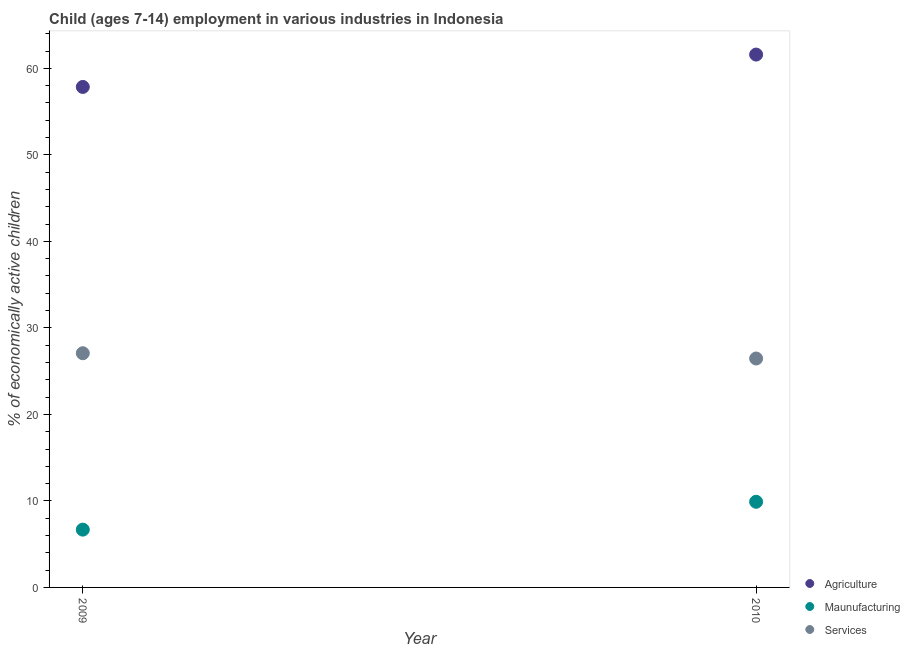How many different coloured dotlines are there?
Give a very brief answer. 3. What is the percentage of economically active children in manufacturing in 2009?
Offer a terse response. 6.68. Across all years, what is the maximum percentage of economically active children in agriculture?
Keep it short and to the point. 61.59. Across all years, what is the minimum percentage of economically active children in manufacturing?
Offer a very short reply. 6.68. In which year was the percentage of economically active children in agriculture maximum?
Give a very brief answer. 2010. What is the total percentage of economically active children in agriculture in the graph?
Your answer should be compact. 119.44. What is the difference between the percentage of economically active children in manufacturing in 2009 and that in 2010?
Give a very brief answer. -3.22. What is the difference between the percentage of economically active children in agriculture in 2010 and the percentage of economically active children in manufacturing in 2009?
Your answer should be compact. 54.91. What is the average percentage of economically active children in manufacturing per year?
Make the answer very short. 8.29. In the year 2010, what is the difference between the percentage of economically active children in services and percentage of economically active children in manufacturing?
Keep it short and to the point. 16.56. What is the ratio of the percentage of economically active children in services in 2009 to that in 2010?
Your answer should be compact. 1.02. In how many years, is the percentage of economically active children in services greater than the average percentage of economically active children in services taken over all years?
Your answer should be compact. 1. Is it the case that in every year, the sum of the percentage of economically active children in agriculture and percentage of economically active children in manufacturing is greater than the percentage of economically active children in services?
Provide a succinct answer. Yes. How many dotlines are there?
Provide a short and direct response. 3. How many years are there in the graph?
Provide a succinct answer. 2. What is the difference between two consecutive major ticks on the Y-axis?
Your response must be concise. 10. Are the values on the major ticks of Y-axis written in scientific E-notation?
Ensure brevity in your answer.  No. Does the graph contain any zero values?
Your answer should be very brief. No. Where does the legend appear in the graph?
Make the answer very short. Bottom right. How many legend labels are there?
Keep it short and to the point. 3. What is the title of the graph?
Keep it short and to the point. Child (ages 7-14) employment in various industries in Indonesia. What is the label or title of the Y-axis?
Your answer should be compact. % of economically active children. What is the % of economically active children of Agriculture in 2009?
Your answer should be very brief. 57.85. What is the % of economically active children in Maunufacturing in 2009?
Offer a very short reply. 6.68. What is the % of economically active children of Services in 2009?
Provide a short and direct response. 27.07. What is the % of economically active children of Agriculture in 2010?
Your answer should be very brief. 61.59. What is the % of economically active children in Maunufacturing in 2010?
Offer a very short reply. 9.9. What is the % of economically active children of Services in 2010?
Provide a short and direct response. 26.46. Across all years, what is the maximum % of economically active children in Agriculture?
Provide a short and direct response. 61.59. Across all years, what is the maximum % of economically active children of Maunufacturing?
Your answer should be very brief. 9.9. Across all years, what is the maximum % of economically active children in Services?
Your answer should be compact. 27.07. Across all years, what is the minimum % of economically active children in Agriculture?
Provide a short and direct response. 57.85. Across all years, what is the minimum % of economically active children in Maunufacturing?
Give a very brief answer. 6.68. Across all years, what is the minimum % of economically active children in Services?
Ensure brevity in your answer.  26.46. What is the total % of economically active children of Agriculture in the graph?
Keep it short and to the point. 119.44. What is the total % of economically active children of Maunufacturing in the graph?
Your answer should be compact. 16.58. What is the total % of economically active children in Services in the graph?
Your answer should be very brief. 53.53. What is the difference between the % of economically active children in Agriculture in 2009 and that in 2010?
Offer a terse response. -3.74. What is the difference between the % of economically active children of Maunufacturing in 2009 and that in 2010?
Provide a short and direct response. -3.22. What is the difference between the % of economically active children of Services in 2009 and that in 2010?
Your response must be concise. 0.61. What is the difference between the % of economically active children of Agriculture in 2009 and the % of economically active children of Maunufacturing in 2010?
Provide a succinct answer. 47.95. What is the difference between the % of economically active children of Agriculture in 2009 and the % of economically active children of Services in 2010?
Your answer should be very brief. 31.39. What is the difference between the % of economically active children of Maunufacturing in 2009 and the % of economically active children of Services in 2010?
Keep it short and to the point. -19.78. What is the average % of economically active children in Agriculture per year?
Your response must be concise. 59.72. What is the average % of economically active children of Maunufacturing per year?
Your answer should be very brief. 8.29. What is the average % of economically active children of Services per year?
Ensure brevity in your answer.  26.77. In the year 2009, what is the difference between the % of economically active children in Agriculture and % of economically active children in Maunufacturing?
Your answer should be compact. 51.17. In the year 2009, what is the difference between the % of economically active children in Agriculture and % of economically active children in Services?
Your response must be concise. 30.78. In the year 2009, what is the difference between the % of economically active children of Maunufacturing and % of economically active children of Services?
Your answer should be compact. -20.39. In the year 2010, what is the difference between the % of economically active children of Agriculture and % of economically active children of Maunufacturing?
Provide a succinct answer. 51.69. In the year 2010, what is the difference between the % of economically active children of Agriculture and % of economically active children of Services?
Give a very brief answer. 35.13. In the year 2010, what is the difference between the % of economically active children of Maunufacturing and % of economically active children of Services?
Your answer should be compact. -16.56. What is the ratio of the % of economically active children in Agriculture in 2009 to that in 2010?
Offer a very short reply. 0.94. What is the ratio of the % of economically active children in Maunufacturing in 2009 to that in 2010?
Provide a succinct answer. 0.67. What is the ratio of the % of economically active children in Services in 2009 to that in 2010?
Offer a very short reply. 1.02. What is the difference between the highest and the second highest % of economically active children in Agriculture?
Provide a short and direct response. 3.74. What is the difference between the highest and the second highest % of economically active children of Maunufacturing?
Your response must be concise. 3.22. What is the difference between the highest and the second highest % of economically active children in Services?
Provide a succinct answer. 0.61. What is the difference between the highest and the lowest % of economically active children of Agriculture?
Make the answer very short. 3.74. What is the difference between the highest and the lowest % of economically active children in Maunufacturing?
Your answer should be compact. 3.22. What is the difference between the highest and the lowest % of economically active children in Services?
Offer a terse response. 0.61. 